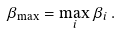Convert formula to latex. <formula><loc_0><loc_0><loc_500><loc_500>\beta _ { \max } = \max _ { i } \beta _ { i } \, .</formula> 